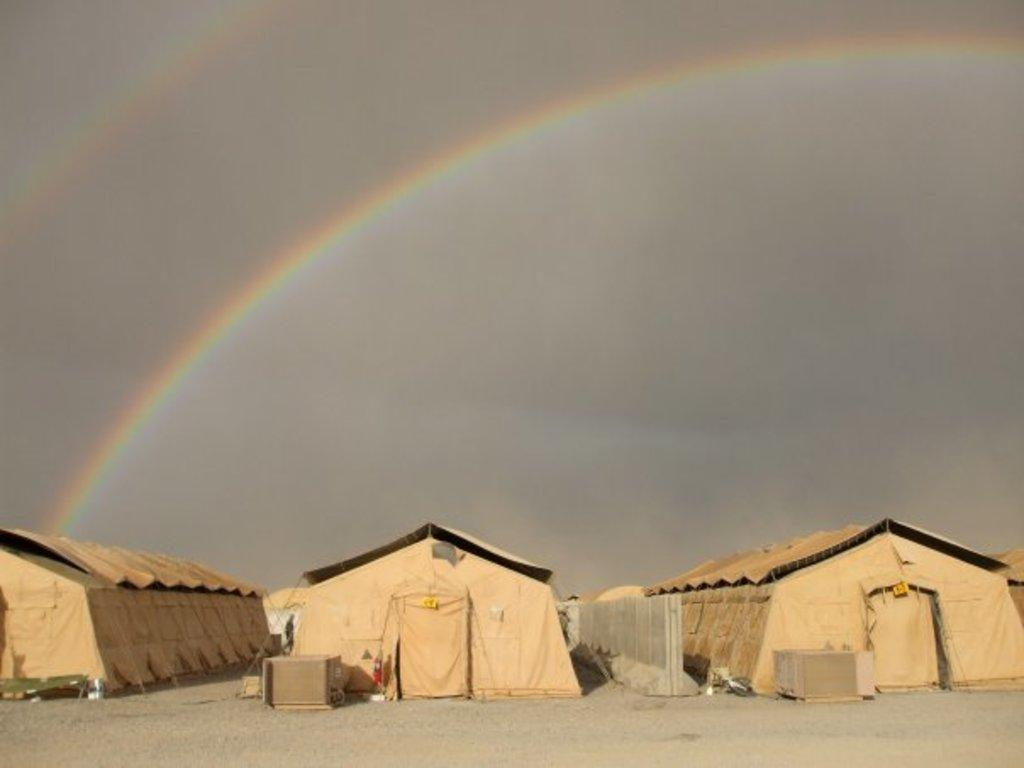What type of structures can be seen at the bottom of the image? There are tents at the bottom of the image. What is visible in the background of the image? There is a sky visible in the background of the image. What additional feature can be seen in the sky? There is a rainbow in the sky. What type of prose is being recited by the quarter in the image? There is no prose or quarter present in the image. How does the rainbow contribute to the arithmetic problem in the image? There is no arithmetic problem or rainbow-related calculation in the image. 